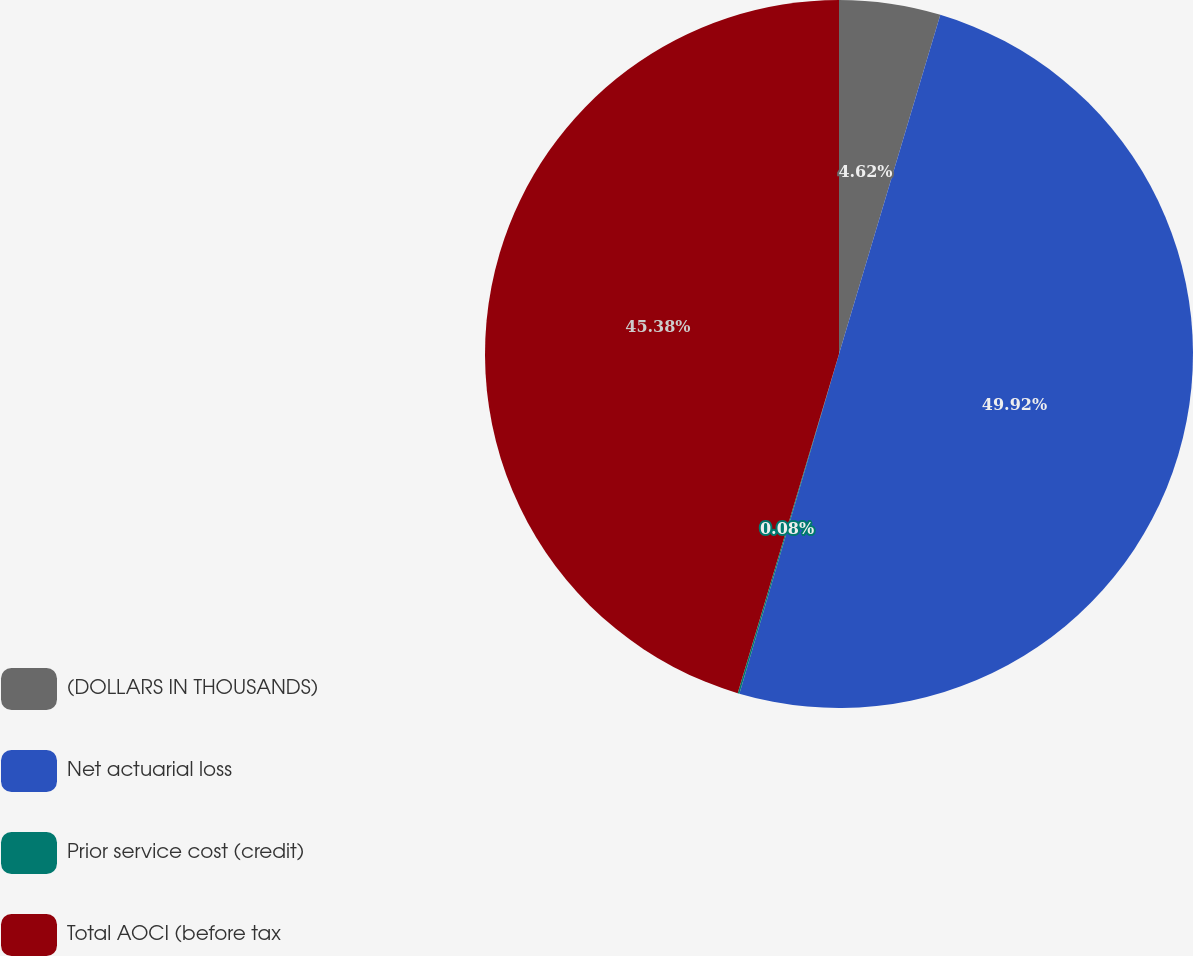<chart> <loc_0><loc_0><loc_500><loc_500><pie_chart><fcel>(DOLLARS IN THOUSANDS)<fcel>Net actuarial loss<fcel>Prior service cost (credit)<fcel>Total AOCI (before tax<nl><fcel>4.62%<fcel>49.92%<fcel>0.08%<fcel>45.38%<nl></chart> 